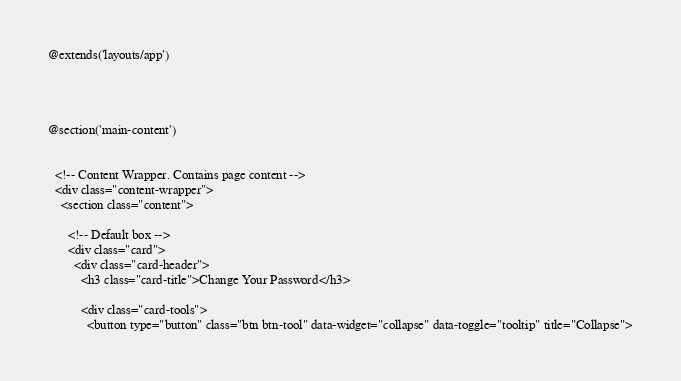Convert code to text. <code><loc_0><loc_0><loc_500><loc_500><_PHP_>@extends('layouts/app')




@section('main-content')

       
  <!-- Content Wrapper. Contains page content -->
  <div class="content-wrapper">
    <section class="content">

      <!-- Default box -->
      <div class="card">
        <div class="card-header">
          <h3 class="card-title">Change Your Password</h3>

          <div class="card-tools">
            <button type="button" class="btn btn-tool" data-widget="collapse" data-toggle="tooltip" title="Collapse"></code> 